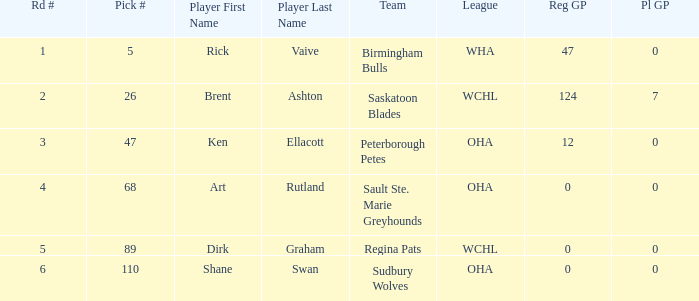How many rounds exist for picks under 5? 0.0. 